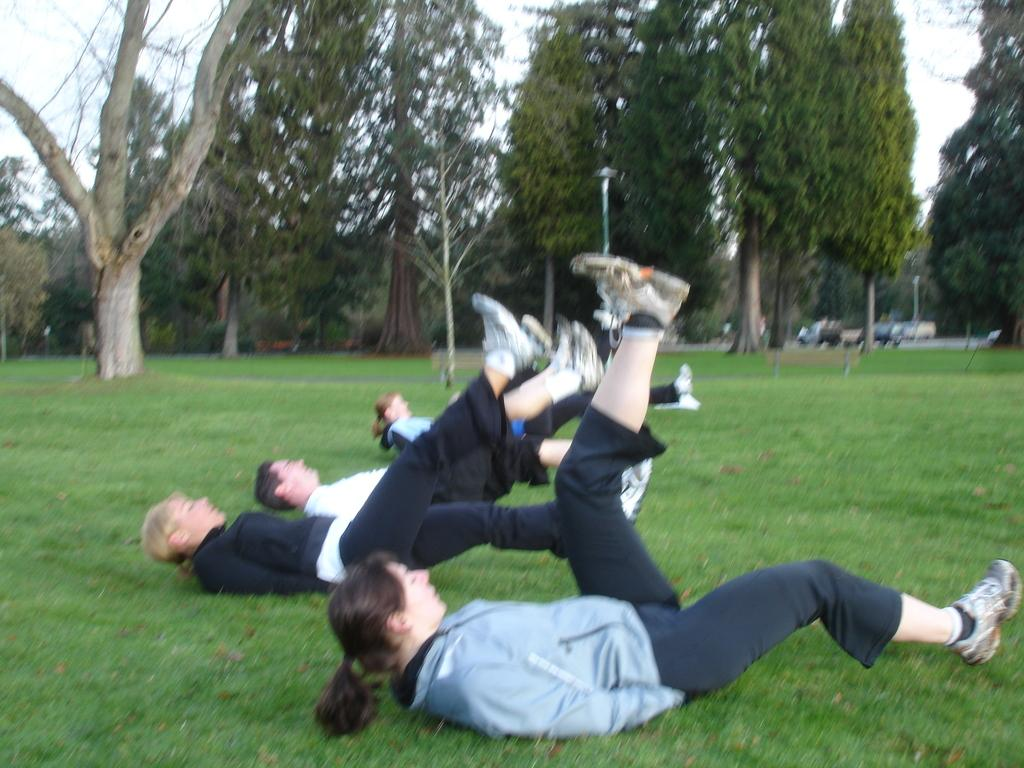What are the people in the image doing? The people are lying on a grassy land in the image. Where is the grassy land located in the image? The grassy land is at the bottom of the image. What can be seen in the background of the image? There are trees in the background of the image. What is visible at the top of the image? The sky is visible at the top of the image. What type of drawer can be seen in the image? There is no drawer present in the image. What trick are the people performing in the image? There is no trick being performed in the image; the people are simply lying on the grassy land. 